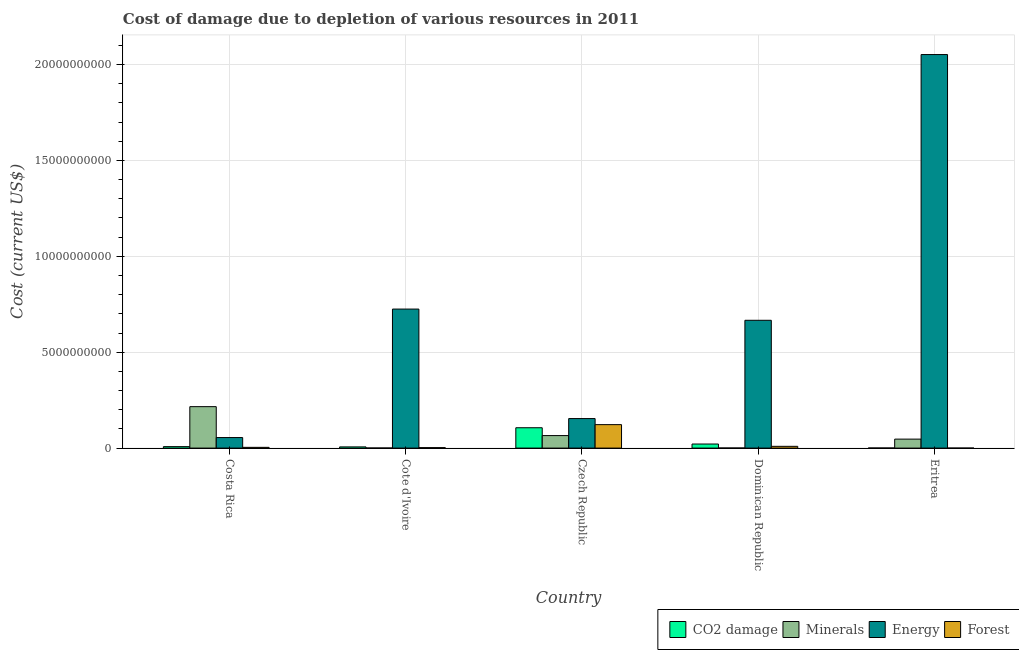How many different coloured bars are there?
Your answer should be very brief. 4. How many groups of bars are there?
Offer a very short reply. 5. Are the number of bars per tick equal to the number of legend labels?
Ensure brevity in your answer.  Yes. Are the number of bars on each tick of the X-axis equal?
Keep it short and to the point. Yes. How many bars are there on the 3rd tick from the left?
Give a very brief answer. 4. In how many cases, is the number of bars for a given country not equal to the number of legend labels?
Your answer should be very brief. 0. What is the cost of damage due to depletion of forests in Costa Rica?
Keep it short and to the point. 3.86e+07. Across all countries, what is the maximum cost of damage due to depletion of energy?
Your response must be concise. 2.05e+1. Across all countries, what is the minimum cost of damage due to depletion of forests?
Offer a very short reply. 3.45e+05. In which country was the cost of damage due to depletion of minerals maximum?
Keep it short and to the point. Costa Rica. In which country was the cost of damage due to depletion of forests minimum?
Make the answer very short. Eritrea. What is the total cost of damage due to depletion of energy in the graph?
Provide a short and direct response. 3.65e+1. What is the difference between the cost of damage due to depletion of forests in Cote d'Ivoire and that in Czech Republic?
Ensure brevity in your answer.  -1.20e+09. What is the difference between the cost of damage due to depletion of minerals in Czech Republic and the cost of damage due to depletion of energy in Eritrea?
Ensure brevity in your answer.  -1.99e+1. What is the average cost of damage due to depletion of minerals per country?
Offer a terse response. 6.58e+08. What is the difference between the cost of damage due to depletion of minerals and cost of damage due to depletion of forests in Eritrea?
Keep it short and to the point. 4.68e+08. In how many countries, is the cost of damage due to depletion of forests greater than 18000000000 US$?
Your answer should be compact. 0. What is the ratio of the cost of damage due to depletion of energy in Costa Rica to that in Cote d'Ivoire?
Your answer should be very brief. 0.08. Is the cost of damage due to depletion of minerals in Costa Rica less than that in Eritrea?
Your response must be concise. No. What is the difference between the highest and the second highest cost of damage due to depletion of minerals?
Your answer should be very brief. 1.51e+09. What is the difference between the highest and the lowest cost of damage due to depletion of energy?
Keep it short and to the point. 2.00e+1. In how many countries, is the cost of damage due to depletion of minerals greater than the average cost of damage due to depletion of minerals taken over all countries?
Provide a succinct answer. 1. Is the sum of the cost of damage due to depletion of coal in Cote d'Ivoire and Dominican Republic greater than the maximum cost of damage due to depletion of forests across all countries?
Your answer should be very brief. No. What does the 3rd bar from the left in Cote d'Ivoire represents?
Provide a short and direct response. Energy. What does the 3rd bar from the right in Cote d'Ivoire represents?
Give a very brief answer. Minerals. How many countries are there in the graph?
Make the answer very short. 5. Does the graph contain grids?
Your response must be concise. Yes. Where does the legend appear in the graph?
Offer a terse response. Bottom right. How many legend labels are there?
Keep it short and to the point. 4. How are the legend labels stacked?
Make the answer very short. Horizontal. What is the title of the graph?
Your answer should be very brief. Cost of damage due to depletion of various resources in 2011 . What is the label or title of the X-axis?
Make the answer very short. Country. What is the label or title of the Y-axis?
Provide a short and direct response. Cost (current US$). What is the Cost (current US$) in CO2 damage in Costa Rica?
Offer a very short reply. 7.60e+07. What is the Cost (current US$) in Minerals in Costa Rica?
Your response must be concise. 2.16e+09. What is the Cost (current US$) in Energy in Costa Rica?
Your answer should be very brief. 5.50e+08. What is the Cost (current US$) of Forest in Costa Rica?
Offer a terse response. 3.86e+07. What is the Cost (current US$) of CO2 damage in Cote d'Ivoire?
Keep it short and to the point. 6.25e+07. What is the Cost (current US$) of Minerals in Cote d'Ivoire?
Your answer should be very brief. 4.22e+06. What is the Cost (current US$) in Energy in Cote d'Ivoire?
Give a very brief answer. 7.25e+09. What is the Cost (current US$) of Forest in Cote d'Ivoire?
Your response must be concise. 2.43e+07. What is the Cost (current US$) in CO2 damage in Czech Republic?
Provide a short and direct response. 1.06e+09. What is the Cost (current US$) of Minerals in Czech Republic?
Give a very brief answer. 6.52e+08. What is the Cost (current US$) in Energy in Czech Republic?
Make the answer very short. 1.54e+09. What is the Cost (current US$) of Forest in Czech Republic?
Make the answer very short. 1.22e+09. What is the Cost (current US$) of CO2 damage in Dominican Republic?
Offer a very short reply. 2.12e+08. What is the Cost (current US$) of Minerals in Dominican Republic?
Your answer should be very brief. 4.44e+06. What is the Cost (current US$) in Energy in Dominican Republic?
Make the answer very short. 6.66e+09. What is the Cost (current US$) in Forest in Dominican Republic?
Give a very brief answer. 9.16e+07. What is the Cost (current US$) in CO2 damage in Eritrea?
Provide a succinct answer. 5.05e+06. What is the Cost (current US$) in Minerals in Eritrea?
Your answer should be compact. 4.68e+08. What is the Cost (current US$) in Energy in Eritrea?
Your answer should be very brief. 2.05e+1. What is the Cost (current US$) of Forest in Eritrea?
Provide a succinct answer. 3.45e+05. Across all countries, what is the maximum Cost (current US$) in CO2 damage?
Ensure brevity in your answer.  1.06e+09. Across all countries, what is the maximum Cost (current US$) of Minerals?
Your response must be concise. 2.16e+09. Across all countries, what is the maximum Cost (current US$) in Energy?
Your answer should be very brief. 2.05e+1. Across all countries, what is the maximum Cost (current US$) in Forest?
Give a very brief answer. 1.22e+09. Across all countries, what is the minimum Cost (current US$) of CO2 damage?
Make the answer very short. 5.05e+06. Across all countries, what is the minimum Cost (current US$) of Minerals?
Provide a succinct answer. 4.22e+06. Across all countries, what is the minimum Cost (current US$) of Energy?
Your answer should be compact. 5.50e+08. Across all countries, what is the minimum Cost (current US$) of Forest?
Keep it short and to the point. 3.45e+05. What is the total Cost (current US$) in CO2 damage in the graph?
Ensure brevity in your answer.  1.42e+09. What is the total Cost (current US$) of Minerals in the graph?
Offer a very short reply. 3.29e+09. What is the total Cost (current US$) in Energy in the graph?
Give a very brief answer. 3.65e+1. What is the total Cost (current US$) in Forest in the graph?
Provide a short and direct response. 1.38e+09. What is the difference between the Cost (current US$) of CO2 damage in Costa Rica and that in Cote d'Ivoire?
Ensure brevity in your answer.  1.35e+07. What is the difference between the Cost (current US$) in Minerals in Costa Rica and that in Cote d'Ivoire?
Your answer should be compact. 2.16e+09. What is the difference between the Cost (current US$) in Energy in Costa Rica and that in Cote d'Ivoire?
Provide a short and direct response. -6.70e+09. What is the difference between the Cost (current US$) of Forest in Costa Rica and that in Cote d'Ivoire?
Keep it short and to the point. 1.43e+07. What is the difference between the Cost (current US$) of CO2 damage in Costa Rica and that in Czech Republic?
Your answer should be compact. -9.85e+08. What is the difference between the Cost (current US$) of Minerals in Costa Rica and that in Czech Republic?
Offer a very short reply. 1.51e+09. What is the difference between the Cost (current US$) of Energy in Costa Rica and that in Czech Republic?
Keep it short and to the point. -9.89e+08. What is the difference between the Cost (current US$) in Forest in Costa Rica and that in Czech Republic?
Your answer should be very brief. -1.18e+09. What is the difference between the Cost (current US$) in CO2 damage in Costa Rica and that in Dominican Republic?
Keep it short and to the point. -1.36e+08. What is the difference between the Cost (current US$) of Minerals in Costa Rica and that in Dominican Republic?
Keep it short and to the point. 2.16e+09. What is the difference between the Cost (current US$) in Energy in Costa Rica and that in Dominican Republic?
Your response must be concise. -6.11e+09. What is the difference between the Cost (current US$) in Forest in Costa Rica and that in Dominican Republic?
Ensure brevity in your answer.  -5.30e+07. What is the difference between the Cost (current US$) in CO2 damage in Costa Rica and that in Eritrea?
Your answer should be compact. 7.10e+07. What is the difference between the Cost (current US$) of Minerals in Costa Rica and that in Eritrea?
Offer a terse response. 1.69e+09. What is the difference between the Cost (current US$) of Energy in Costa Rica and that in Eritrea?
Provide a short and direct response. -2.00e+1. What is the difference between the Cost (current US$) in Forest in Costa Rica and that in Eritrea?
Provide a short and direct response. 3.82e+07. What is the difference between the Cost (current US$) in CO2 damage in Cote d'Ivoire and that in Czech Republic?
Offer a very short reply. -9.99e+08. What is the difference between the Cost (current US$) in Minerals in Cote d'Ivoire and that in Czech Republic?
Your answer should be very brief. -6.48e+08. What is the difference between the Cost (current US$) of Energy in Cote d'Ivoire and that in Czech Republic?
Offer a terse response. 5.71e+09. What is the difference between the Cost (current US$) in Forest in Cote d'Ivoire and that in Czech Republic?
Keep it short and to the point. -1.20e+09. What is the difference between the Cost (current US$) of CO2 damage in Cote d'Ivoire and that in Dominican Republic?
Give a very brief answer. -1.50e+08. What is the difference between the Cost (current US$) in Minerals in Cote d'Ivoire and that in Dominican Republic?
Offer a terse response. -2.25e+05. What is the difference between the Cost (current US$) of Energy in Cote d'Ivoire and that in Dominican Republic?
Ensure brevity in your answer.  5.85e+08. What is the difference between the Cost (current US$) of Forest in Cote d'Ivoire and that in Dominican Republic?
Keep it short and to the point. -6.73e+07. What is the difference between the Cost (current US$) of CO2 damage in Cote d'Ivoire and that in Eritrea?
Your response must be concise. 5.74e+07. What is the difference between the Cost (current US$) of Minerals in Cote d'Ivoire and that in Eritrea?
Make the answer very short. -4.64e+08. What is the difference between the Cost (current US$) of Energy in Cote d'Ivoire and that in Eritrea?
Keep it short and to the point. -1.33e+1. What is the difference between the Cost (current US$) in Forest in Cote d'Ivoire and that in Eritrea?
Provide a short and direct response. 2.40e+07. What is the difference between the Cost (current US$) in CO2 damage in Czech Republic and that in Dominican Republic?
Provide a short and direct response. 8.49e+08. What is the difference between the Cost (current US$) in Minerals in Czech Republic and that in Dominican Republic?
Ensure brevity in your answer.  6.48e+08. What is the difference between the Cost (current US$) in Energy in Czech Republic and that in Dominican Republic?
Your answer should be very brief. -5.13e+09. What is the difference between the Cost (current US$) of Forest in Czech Republic and that in Dominican Republic?
Provide a succinct answer. 1.13e+09. What is the difference between the Cost (current US$) in CO2 damage in Czech Republic and that in Eritrea?
Keep it short and to the point. 1.06e+09. What is the difference between the Cost (current US$) in Minerals in Czech Republic and that in Eritrea?
Offer a terse response. 1.84e+08. What is the difference between the Cost (current US$) in Energy in Czech Republic and that in Eritrea?
Keep it short and to the point. -1.90e+1. What is the difference between the Cost (current US$) of Forest in Czech Republic and that in Eritrea?
Offer a very short reply. 1.22e+09. What is the difference between the Cost (current US$) of CO2 damage in Dominican Republic and that in Eritrea?
Offer a very short reply. 2.07e+08. What is the difference between the Cost (current US$) of Minerals in Dominican Republic and that in Eritrea?
Offer a very short reply. -4.64e+08. What is the difference between the Cost (current US$) in Energy in Dominican Republic and that in Eritrea?
Your answer should be very brief. -1.39e+1. What is the difference between the Cost (current US$) in Forest in Dominican Republic and that in Eritrea?
Your answer should be very brief. 9.12e+07. What is the difference between the Cost (current US$) in CO2 damage in Costa Rica and the Cost (current US$) in Minerals in Cote d'Ivoire?
Offer a terse response. 7.18e+07. What is the difference between the Cost (current US$) in CO2 damage in Costa Rica and the Cost (current US$) in Energy in Cote d'Ivoire?
Provide a succinct answer. -7.17e+09. What is the difference between the Cost (current US$) of CO2 damage in Costa Rica and the Cost (current US$) of Forest in Cote d'Ivoire?
Keep it short and to the point. 5.17e+07. What is the difference between the Cost (current US$) of Minerals in Costa Rica and the Cost (current US$) of Energy in Cote d'Ivoire?
Ensure brevity in your answer.  -5.09e+09. What is the difference between the Cost (current US$) in Minerals in Costa Rica and the Cost (current US$) in Forest in Cote d'Ivoire?
Your answer should be compact. 2.14e+09. What is the difference between the Cost (current US$) of Energy in Costa Rica and the Cost (current US$) of Forest in Cote d'Ivoire?
Provide a succinct answer. 5.25e+08. What is the difference between the Cost (current US$) of CO2 damage in Costa Rica and the Cost (current US$) of Minerals in Czech Republic?
Your response must be concise. -5.76e+08. What is the difference between the Cost (current US$) in CO2 damage in Costa Rica and the Cost (current US$) in Energy in Czech Republic?
Ensure brevity in your answer.  -1.46e+09. What is the difference between the Cost (current US$) of CO2 damage in Costa Rica and the Cost (current US$) of Forest in Czech Republic?
Your answer should be compact. -1.15e+09. What is the difference between the Cost (current US$) in Minerals in Costa Rica and the Cost (current US$) in Energy in Czech Republic?
Make the answer very short. 6.22e+08. What is the difference between the Cost (current US$) of Minerals in Costa Rica and the Cost (current US$) of Forest in Czech Republic?
Your answer should be compact. 9.38e+08. What is the difference between the Cost (current US$) in Energy in Costa Rica and the Cost (current US$) in Forest in Czech Republic?
Provide a succinct answer. -6.74e+08. What is the difference between the Cost (current US$) in CO2 damage in Costa Rica and the Cost (current US$) in Minerals in Dominican Republic?
Your response must be concise. 7.16e+07. What is the difference between the Cost (current US$) in CO2 damage in Costa Rica and the Cost (current US$) in Energy in Dominican Republic?
Make the answer very short. -6.59e+09. What is the difference between the Cost (current US$) in CO2 damage in Costa Rica and the Cost (current US$) in Forest in Dominican Republic?
Provide a succinct answer. -1.55e+07. What is the difference between the Cost (current US$) of Minerals in Costa Rica and the Cost (current US$) of Energy in Dominican Republic?
Your answer should be compact. -4.50e+09. What is the difference between the Cost (current US$) in Minerals in Costa Rica and the Cost (current US$) in Forest in Dominican Republic?
Give a very brief answer. 2.07e+09. What is the difference between the Cost (current US$) of Energy in Costa Rica and the Cost (current US$) of Forest in Dominican Republic?
Offer a very short reply. 4.58e+08. What is the difference between the Cost (current US$) in CO2 damage in Costa Rica and the Cost (current US$) in Minerals in Eritrea?
Give a very brief answer. -3.92e+08. What is the difference between the Cost (current US$) of CO2 damage in Costa Rica and the Cost (current US$) of Energy in Eritrea?
Keep it short and to the point. -2.04e+1. What is the difference between the Cost (current US$) of CO2 damage in Costa Rica and the Cost (current US$) of Forest in Eritrea?
Provide a short and direct response. 7.57e+07. What is the difference between the Cost (current US$) in Minerals in Costa Rica and the Cost (current US$) in Energy in Eritrea?
Offer a very short reply. -1.84e+1. What is the difference between the Cost (current US$) in Minerals in Costa Rica and the Cost (current US$) in Forest in Eritrea?
Offer a terse response. 2.16e+09. What is the difference between the Cost (current US$) of Energy in Costa Rica and the Cost (current US$) of Forest in Eritrea?
Provide a succinct answer. 5.49e+08. What is the difference between the Cost (current US$) of CO2 damage in Cote d'Ivoire and the Cost (current US$) of Minerals in Czech Republic?
Give a very brief answer. -5.90e+08. What is the difference between the Cost (current US$) of CO2 damage in Cote d'Ivoire and the Cost (current US$) of Energy in Czech Republic?
Your response must be concise. -1.48e+09. What is the difference between the Cost (current US$) of CO2 damage in Cote d'Ivoire and the Cost (current US$) of Forest in Czech Republic?
Your response must be concise. -1.16e+09. What is the difference between the Cost (current US$) of Minerals in Cote d'Ivoire and the Cost (current US$) of Energy in Czech Republic?
Give a very brief answer. -1.53e+09. What is the difference between the Cost (current US$) of Minerals in Cote d'Ivoire and the Cost (current US$) of Forest in Czech Republic?
Your response must be concise. -1.22e+09. What is the difference between the Cost (current US$) of Energy in Cote d'Ivoire and the Cost (current US$) of Forest in Czech Republic?
Offer a very short reply. 6.03e+09. What is the difference between the Cost (current US$) of CO2 damage in Cote d'Ivoire and the Cost (current US$) of Minerals in Dominican Republic?
Offer a terse response. 5.80e+07. What is the difference between the Cost (current US$) in CO2 damage in Cote d'Ivoire and the Cost (current US$) in Energy in Dominican Republic?
Your answer should be very brief. -6.60e+09. What is the difference between the Cost (current US$) in CO2 damage in Cote d'Ivoire and the Cost (current US$) in Forest in Dominican Republic?
Your answer should be compact. -2.91e+07. What is the difference between the Cost (current US$) in Minerals in Cote d'Ivoire and the Cost (current US$) in Energy in Dominican Republic?
Give a very brief answer. -6.66e+09. What is the difference between the Cost (current US$) of Minerals in Cote d'Ivoire and the Cost (current US$) of Forest in Dominican Republic?
Your response must be concise. -8.74e+07. What is the difference between the Cost (current US$) in Energy in Cote d'Ivoire and the Cost (current US$) in Forest in Dominican Republic?
Your response must be concise. 7.16e+09. What is the difference between the Cost (current US$) of CO2 damage in Cote d'Ivoire and the Cost (current US$) of Minerals in Eritrea?
Offer a terse response. -4.06e+08. What is the difference between the Cost (current US$) in CO2 damage in Cote d'Ivoire and the Cost (current US$) in Energy in Eritrea?
Your answer should be compact. -2.05e+1. What is the difference between the Cost (current US$) of CO2 damage in Cote d'Ivoire and the Cost (current US$) of Forest in Eritrea?
Make the answer very short. 6.21e+07. What is the difference between the Cost (current US$) in Minerals in Cote d'Ivoire and the Cost (current US$) in Energy in Eritrea?
Ensure brevity in your answer.  -2.05e+1. What is the difference between the Cost (current US$) in Minerals in Cote d'Ivoire and the Cost (current US$) in Forest in Eritrea?
Keep it short and to the point. 3.87e+06. What is the difference between the Cost (current US$) in Energy in Cote d'Ivoire and the Cost (current US$) in Forest in Eritrea?
Make the answer very short. 7.25e+09. What is the difference between the Cost (current US$) of CO2 damage in Czech Republic and the Cost (current US$) of Minerals in Dominican Republic?
Your answer should be very brief. 1.06e+09. What is the difference between the Cost (current US$) in CO2 damage in Czech Republic and the Cost (current US$) in Energy in Dominican Republic?
Provide a succinct answer. -5.60e+09. What is the difference between the Cost (current US$) of CO2 damage in Czech Republic and the Cost (current US$) of Forest in Dominican Republic?
Ensure brevity in your answer.  9.70e+08. What is the difference between the Cost (current US$) of Minerals in Czech Republic and the Cost (current US$) of Energy in Dominican Republic?
Your answer should be very brief. -6.01e+09. What is the difference between the Cost (current US$) of Minerals in Czech Republic and the Cost (current US$) of Forest in Dominican Republic?
Your response must be concise. 5.61e+08. What is the difference between the Cost (current US$) in Energy in Czech Republic and the Cost (current US$) in Forest in Dominican Republic?
Your answer should be very brief. 1.45e+09. What is the difference between the Cost (current US$) of CO2 damage in Czech Republic and the Cost (current US$) of Minerals in Eritrea?
Make the answer very short. 5.93e+08. What is the difference between the Cost (current US$) in CO2 damage in Czech Republic and the Cost (current US$) in Energy in Eritrea?
Provide a short and direct response. -1.95e+1. What is the difference between the Cost (current US$) in CO2 damage in Czech Republic and the Cost (current US$) in Forest in Eritrea?
Provide a succinct answer. 1.06e+09. What is the difference between the Cost (current US$) in Minerals in Czech Republic and the Cost (current US$) in Energy in Eritrea?
Your answer should be very brief. -1.99e+1. What is the difference between the Cost (current US$) of Minerals in Czech Republic and the Cost (current US$) of Forest in Eritrea?
Offer a terse response. 6.52e+08. What is the difference between the Cost (current US$) of Energy in Czech Republic and the Cost (current US$) of Forest in Eritrea?
Offer a very short reply. 1.54e+09. What is the difference between the Cost (current US$) in CO2 damage in Dominican Republic and the Cost (current US$) in Minerals in Eritrea?
Give a very brief answer. -2.56e+08. What is the difference between the Cost (current US$) in CO2 damage in Dominican Republic and the Cost (current US$) in Energy in Eritrea?
Make the answer very short. -2.03e+1. What is the difference between the Cost (current US$) in CO2 damage in Dominican Republic and the Cost (current US$) in Forest in Eritrea?
Your answer should be compact. 2.12e+08. What is the difference between the Cost (current US$) of Minerals in Dominican Republic and the Cost (current US$) of Energy in Eritrea?
Offer a terse response. -2.05e+1. What is the difference between the Cost (current US$) in Minerals in Dominican Republic and the Cost (current US$) in Forest in Eritrea?
Offer a very short reply. 4.10e+06. What is the difference between the Cost (current US$) in Energy in Dominican Republic and the Cost (current US$) in Forest in Eritrea?
Your answer should be very brief. 6.66e+09. What is the average Cost (current US$) of CO2 damage per country?
Provide a short and direct response. 2.83e+08. What is the average Cost (current US$) in Minerals per country?
Ensure brevity in your answer.  6.58e+08. What is the average Cost (current US$) of Energy per country?
Provide a succinct answer. 7.30e+09. What is the average Cost (current US$) of Forest per country?
Your answer should be compact. 2.76e+08. What is the difference between the Cost (current US$) of CO2 damage and Cost (current US$) of Minerals in Costa Rica?
Your response must be concise. -2.09e+09. What is the difference between the Cost (current US$) of CO2 damage and Cost (current US$) of Energy in Costa Rica?
Your answer should be compact. -4.74e+08. What is the difference between the Cost (current US$) of CO2 damage and Cost (current US$) of Forest in Costa Rica?
Your answer should be very brief. 3.74e+07. What is the difference between the Cost (current US$) in Minerals and Cost (current US$) in Energy in Costa Rica?
Provide a short and direct response. 1.61e+09. What is the difference between the Cost (current US$) in Minerals and Cost (current US$) in Forest in Costa Rica?
Make the answer very short. 2.12e+09. What is the difference between the Cost (current US$) in Energy and Cost (current US$) in Forest in Costa Rica?
Your answer should be compact. 5.11e+08. What is the difference between the Cost (current US$) in CO2 damage and Cost (current US$) in Minerals in Cote d'Ivoire?
Your response must be concise. 5.83e+07. What is the difference between the Cost (current US$) of CO2 damage and Cost (current US$) of Energy in Cote d'Ivoire?
Make the answer very short. -7.19e+09. What is the difference between the Cost (current US$) of CO2 damage and Cost (current US$) of Forest in Cote d'Ivoire?
Give a very brief answer. 3.82e+07. What is the difference between the Cost (current US$) of Minerals and Cost (current US$) of Energy in Cote d'Ivoire?
Your answer should be compact. -7.25e+09. What is the difference between the Cost (current US$) of Minerals and Cost (current US$) of Forest in Cote d'Ivoire?
Provide a succinct answer. -2.01e+07. What is the difference between the Cost (current US$) in Energy and Cost (current US$) in Forest in Cote d'Ivoire?
Your answer should be very brief. 7.23e+09. What is the difference between the Cost (current US$) in CO2 damage and Cost (current US$) in Minerals in Czech Republic?
Offer a very short reply. 4.09e+08. What is the difference between the Cost (current US$) in CO2 damage and Cost (current US$) in Energy in Czech Republic?
Your answer should be very brief. -4.78e+08. What is the difference between the Cost (current US$) of CO2 damage and Cost (current US$) of Forest in Czech Republic?
Provide a succinct answer. -1.62e+08. What is the difference between the Cost (current US$) in Minerals and Cost (current US$) in Energy in Czech Republic?
Your response must be concise. -8.87e+08. What is the difference between the Cost (current US$) in Minerals and Cost (current US$) in Forest in Czech Republic?
Your answer should be compact. -5.71e+08. What is the difference between the Cost (current US$) of Energy and Cost (current US$) of Forest in Czech Republic?
Give a very brief answer. 3.16e+08. What is the difference between the Cost (current US$) in CO2 damage and Cost (current US$) in Minerals in Dominican Republic?
Offer a very short reply. 2.08e+08. What is the difference between the Cost (current US$) of CO2 damage and Cost (current US$) of Energy in Dominican Republic?
Keep it short and to the point. -6.45e+09. What is the difference between the Cost (current US$) of CO2 damage and Cost (current US$) of Forest in Dominican Republic?
Provide a short and direct response. 1.21e+08. What is the difference between the Cost (current US$) of Minerals and Cost (current US$) of Energy in Dominican Republic?
Your answer should be compact. -6.66e+09. What is the difference between the Cost (current US$) in Minerals and Cost (current US$) in Forest in Dominican Republic?
Your answer should be very brief. -8.71e+07. What is the difference between the Cost (current US$) of Energy and Cost (current US$) of Forest in Dominican Republic?
Your answer should be compact. 6.57e+09. What is the difference between the Cost (current US$) of CO2 damage and Cost (current US$) of Minerals in Eritrea?
Your answer should be very brief. -4.63e+08. What is the difference between the Cost (current US$) of CO2 damage and Cost (current US$) of Energy in Eritrea?
Your response must be concise. -2.05e+1. What is the difference between the Cost (current US$) of CO2 damage and Cost (current US$) of Forest in Eritrea?
Keep it short and to the point. 4.70e+06. What is the difference between the Cost (current US$) in Minerals and Cost (current US$) in Energy in Eritrea?
Ensure brevity in your answer.  -2.01e+1. What is the difference between the Cost (current US$) of Minerals and Cost (current US$) of Forest in Eritrea?
Make the answer very short. 4.68e+08. What is the difference between the Cost (current US$) of Energy and Cost (current US$) of Forest in Eritrea?
Offer a terse response. 2.05e+1. What is the ratio of the Cost (current US$) in CO2 damage in Costa Rica to that in Cote d'Ivoire?
Your response must be concise. 1.22. What is the ratio of the Cost (current US$) in Minerals in Costa Rica to that in Cote d'Ivoire?
Your answer should be very brief. 512.71. What is the ratio of the Cost (current US$) in Energy in Costa Rica to that in Cote d'Ivoire?
Provide a succinct answer. 0.08. What is the ratio of the Cost (current US$) in Forest in Costa Rica to that in Cote d'Ivoire?
Offer a terse response. 1.59. What is the ratio of the Cost (current US$) in CO2 damage in Costa Rica to that in Czech Republic?
Offer a very short reply. 0.07. What is the ratio of the Cost (current US$) of Minerals in Costa Rica to that in Czech Republic?
Keep it short and to the point. 3.31. What is the ratio of the Cost (current US$) in Energy in Costa Rica to that in Czech Republic?
Provide a short and direct response. 0.36. What is the ratio of the Cost (current US$) in Forest in Costa Rica to that in Czech Republic?
Your response must be concise. 0.03. What is the ratio of the Cost (current US$) of CO2 damage in Costa Rica to that in Dominican Republic?
Offer a terse response. 0.36. What is the ratio of the Cost (current US$) in Minerals in Costa Rica to that in Dominican Republic?
Provide a succinct answer. 486.76. What is the ratio of the Cost (current US$) in Energy in Costa Rica to that in Dominican Republic?
Ensure brevity in your answer.  0.08. What is the ratio of the Cost (current US$) of Forest in Costa Rica to that in Dominican Republic?
Make the answer very short. 0.42. What is the ratio of the Cost (current US$) in CO2 damage in Costa Rica to that in Eritrea?
Ensure brevity in your answer.  15.06. What is the ratio of the Cost (current US$) of Minerals in Costa Rica to that in Eritrea?
Your response must be concise. 4.62. What is the ratio of the Cost (current US$) of Energy in Costa Rica to that in Eritrea?
Your answer should be very brief. 0.03. What is the ratio of the Cost (current US$) in Forest in Costa Rica to that in Eritrea?
Your response must be concise. 111.93. What is the ratio of the Cost (current US$) in CO2 damage in Cote d'Ivoire to that in Czech Republic?
Keep it short and to the point. 0.06. What is the ratio of the Cost (current US$) in Minerals in Cote d'Ivoire to that in Czech Republic?
Your response must be concise. 0.01. What is the ratio of the Cost (current US$) of Energy in Cote d'Ivoire to that in Czech Republic?
Offer a very short reply. 4.71. What is the ratio of the Cost (current US$) of Forest in Cote d'Ivoire to that in Czech Republic?
Your answer should be compact. 0.02. What is the ratio of the Cost (current US$) in CO2 damage in Cote d'Ivoire to that in Dominican Republic?
Make the answer very short. 0.29. What is the ratio of the Cost (current US$) of Minerals in Cote d'Ivoire to that in Dominican Republic?
Make the answer very short. 0.95. What is the ratio of the Cost (current US$) of Energy in Cote d'Ivoire to that in Dominican Republic?
Your answer should be compact. 1.09. What is the ratio of the Cost (current US$) in Forest in Cote d'Ivoire to that in Dominican Republic?
Your answer should be compact. 0.27. What is the ratio of the Cost (current US$) of CO2 damage in Cote d'Ivoire to that in Eritrea?
Give a very brief answer. 12.38. What is the ratio of the Cost (current US$) of Minerals in Cote d'Ivoire to that in Eritrea?
Offer a very short reply. 0.01. What is the ratio of the Cost (current US$) in Energy in Cote d'Ivoire to that in Eritrea?
Make the answer very short. 0.35. What is the ratio of the Cost (current US$) in Forest in Cote d'Ivoire to that in Eritrea?
Your answer should be compact. 70.5. What is the ratio of the Cost (current US$) in CO2 damage in Czech Republic to that in Dominican Republic?
Make the answer very short. 5. What is the ratio of the Cost (current US$) of Minerals in Czech Republic to that in Dominican Republic?
Your response must be concise. 146.89. What is the ratio of the Cost (current US$) in Energy in Czech Republic to that in Dominican Republic?
Provide a succinct answer. 0.23. What is the ratio of the Cost (current US$) of Forest in Czech Republic to that in Dominican Republic?
Ensure brevity in your answer.  13.36. What is the ratio of the Cost (current US$) of CO2 damage in Czech Republic to that in Eritrea?
Make the answer very short. 210.26. What is the ratio of the Cost (current US$) of Minerals in Czech Republic to that in Eritrea?
Provide a short and direct response. 1.39. What is the ratio of the Cost (current US$) of Energy in Czech Republic to that in Eritrea?
Ensure brevity in your answer.  0.07. What is the ratio of the Cost (current US$) in Forest in Czech Republic to that in Eritrea?
Provide a short and direct response. 3548.95. What is the ratio of the Cost (current US$) in CO2 damage in Dominican Republic to that in Eritrea?
Your response must be concise. 42.04. What is the ratio of the Cost (current US$) of Minerals in Dominican Republic to that in Eritrea?
Your answer should be compact. 0.01. What is the ratio of the Cost (current US$) of Energy in Dominican Republic to that in Eritrea?
Ensure brevity in your answer.  0.32. What is the ratio of the Cost (current US$) of Forest in Dominican Republic to that in Eritrea?
Offer a terse response. 265.63. What is the difference between the highest and the second highest Cost (current US$) of CO2 damage?
Offer a very short reply. 8.49e+08. What is the difference between the highest and the second highest Cost (current US$) of Minerals?
Provide a succinct answer. 1.51e+09. What is the difference between the highest and the second highest Cost (current US$) of Energy?
Provide a short and direct response. 1.33e+1. What is the difference between the highest and the second highest Cost (current US$) in Forest?
Offer a very short reply. 1.13e+09. What is the difference between the highest and the lowest Cost (current US$) of CO2 damage?
Provide a succinct answer. 1.06e+09. What is the difference between the highest and the lowest Cost (current US$) of Minerals?
Your answer should be very brief. 2.16e+09. What is the difference between the highest and the lowest Cost (current US$) of Energy?
Keep it short and to the point. 2.00e+1. What is the difference between the highest and the lowest Cost (current US$) of Forest?
Keep it short and to the point. 1.22e+09. 